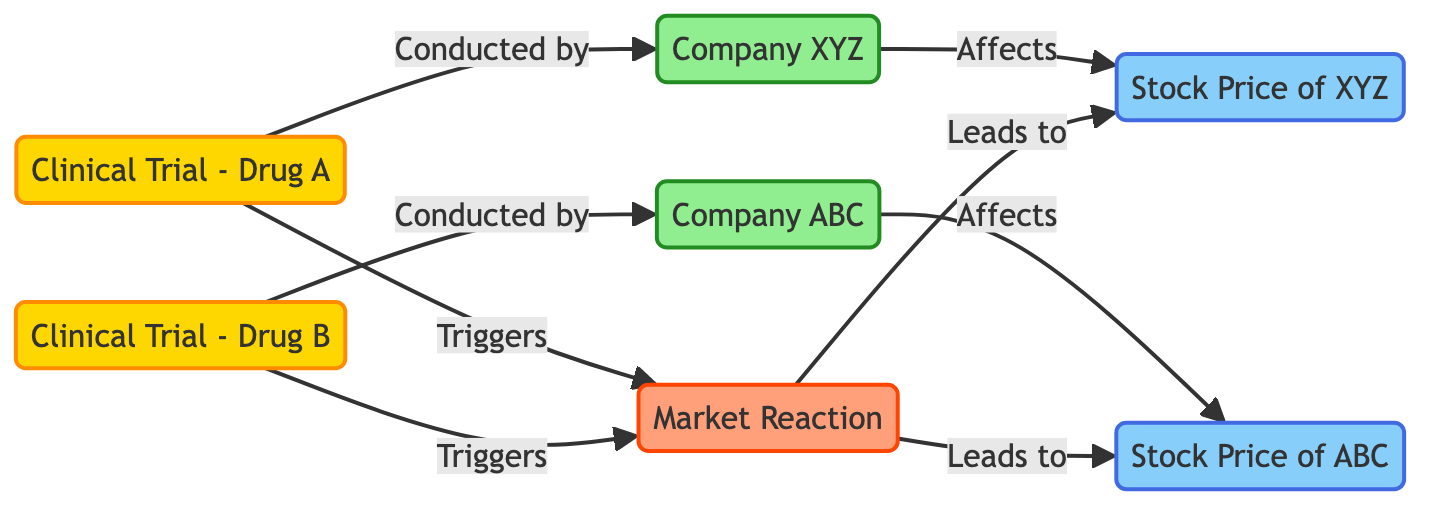What are the two clinical trials represented in the diagram? The diagram includes two events, represented as clinical trials: "Clinical Trial - Drug A" and "Clinical Trial - Drug B." These are distinct nodes labeled within the flowchart.
Answer: Clinical Trial - Drug A, Clinical Trial - Drug B Which companies are conducting the clinical trials? The diagram indicates that "Company XYZ" is conducting "Clinical Trial - Drug A," while "Company ABC" is conducting "Clinical Trial - Drug B." These relationships are drawn as directed edges connecting the trials to the respective companies.
Answer: Company XYZ, Company ABC How many stock price nodes are represented in the diagram? The diagram has two distinct value nodes labeled as stock prices: "Stock Price of XYZ" and "Stock Price of ABC." This can be counted by identifying value nodes in the flowchart.
Answer: 2 What triggers the market reaction according to the diagram? Both clinical trials "Clinical Trial - Drug A" and "Clinical Trial - Drug B" are shown as triggering the "Market Reaction" process in the flowchart. The arrows lead from each trial to the market reaction node.
Answer: Clinical Trial - Drug A, Clinical Trial - Drug B Which stock price is directly affected by "Clinical Trial - Drug A"? The diagram specifies that "Stock Price of XYZ" is directly affected by "Clinical Trial - Drug A," showing a direct link from the trial to this stock price node.
Answer: Stock Price of XYZ If "Clinical Trial - Drug A" results are announced, what will happen next in the diagram? According to the diagram, announcing "Clinical Trial - Drug A" results will trigger the "Market Reaction," which will subsequently affect the stock prices of both companies. This flow can be traced through the arrows connecting the nodes.
Answer: Market Reaction Which node leads to the stock price of Company ABC? The stock price of Company ABC is linked to the "Market Reaction" node, which is influenced by "Clinical Trial - Drug B." The flowchart illustrates this connection.
Answer: Market Reaction How many relationships are shown between events and entities in the diagram? The diagram shows four relationships: "Clinical Trial - Drug A" to "Company XYZ," "Clinical Trial - Drug B" to "Company ABC," as well as the effects on their respective stock prices. This can be counted by tracking the arrows connecting the nodes.
Answer: 4 